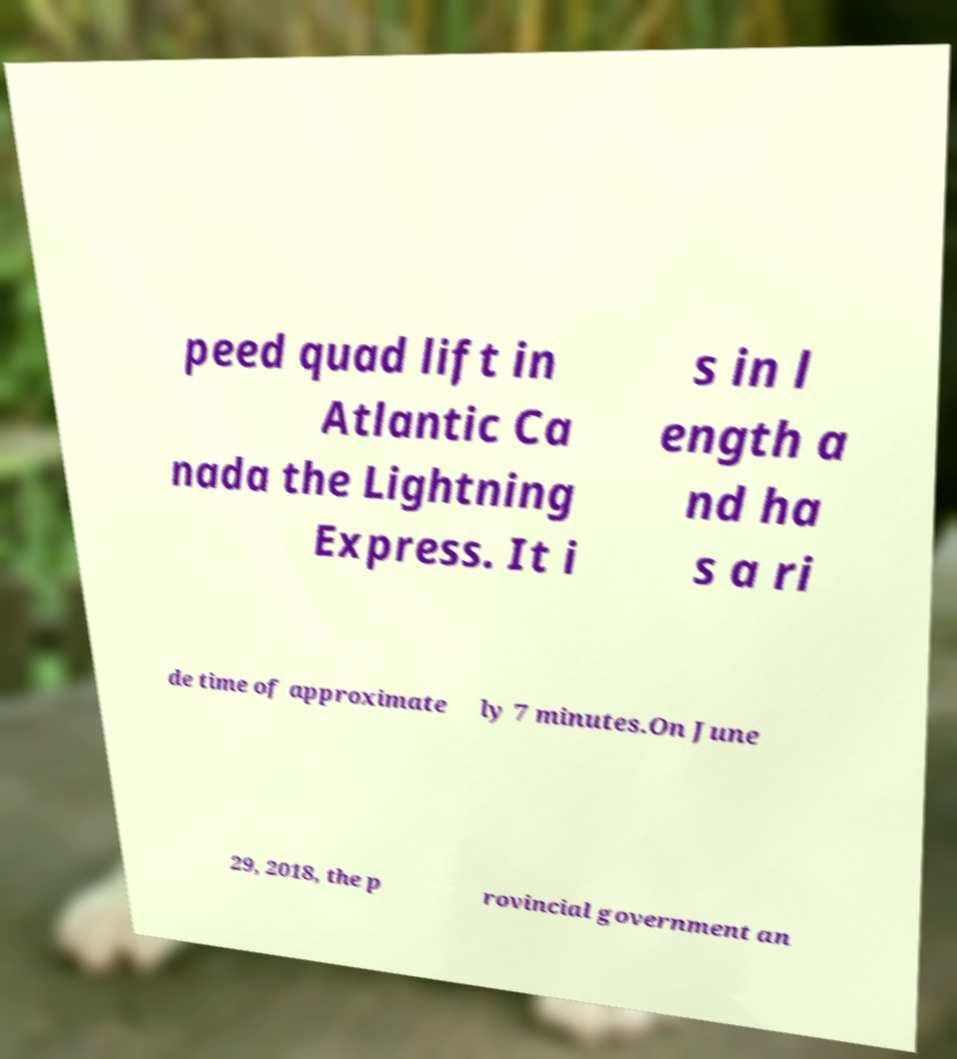Please read and relay the text visible in this image. What does it say? peed quad lift in Atlantic Ca nada the Lightning Express. It i s in l ength a nd ha s a ri de time of approximate ly 7 minutes.On June 29, 2018, the p rovincial government an 